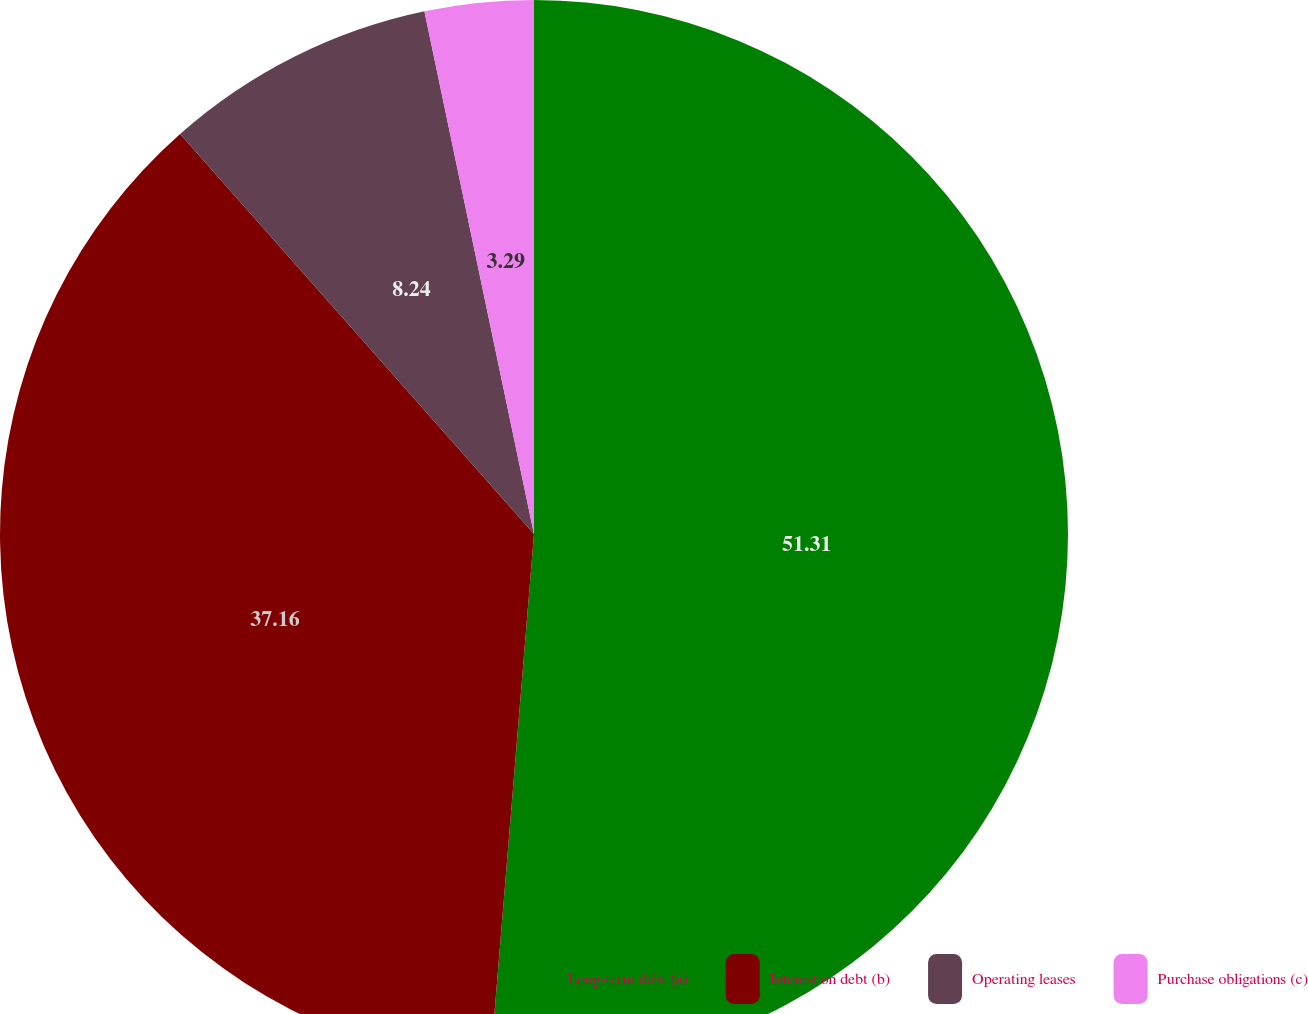Convert chart. <chart><loc_0><loc_0><loc_500><loc_500><pie_chart><fcel>Long-term debt (a)<fcel>Interest on debt (b)<fcel>Operating leases<fcel>Purchase obligations (c)<nl><fcel>51.31%<fcel>37.16%<fcel>8.24%<fcel>3.29%<nl></chart> 